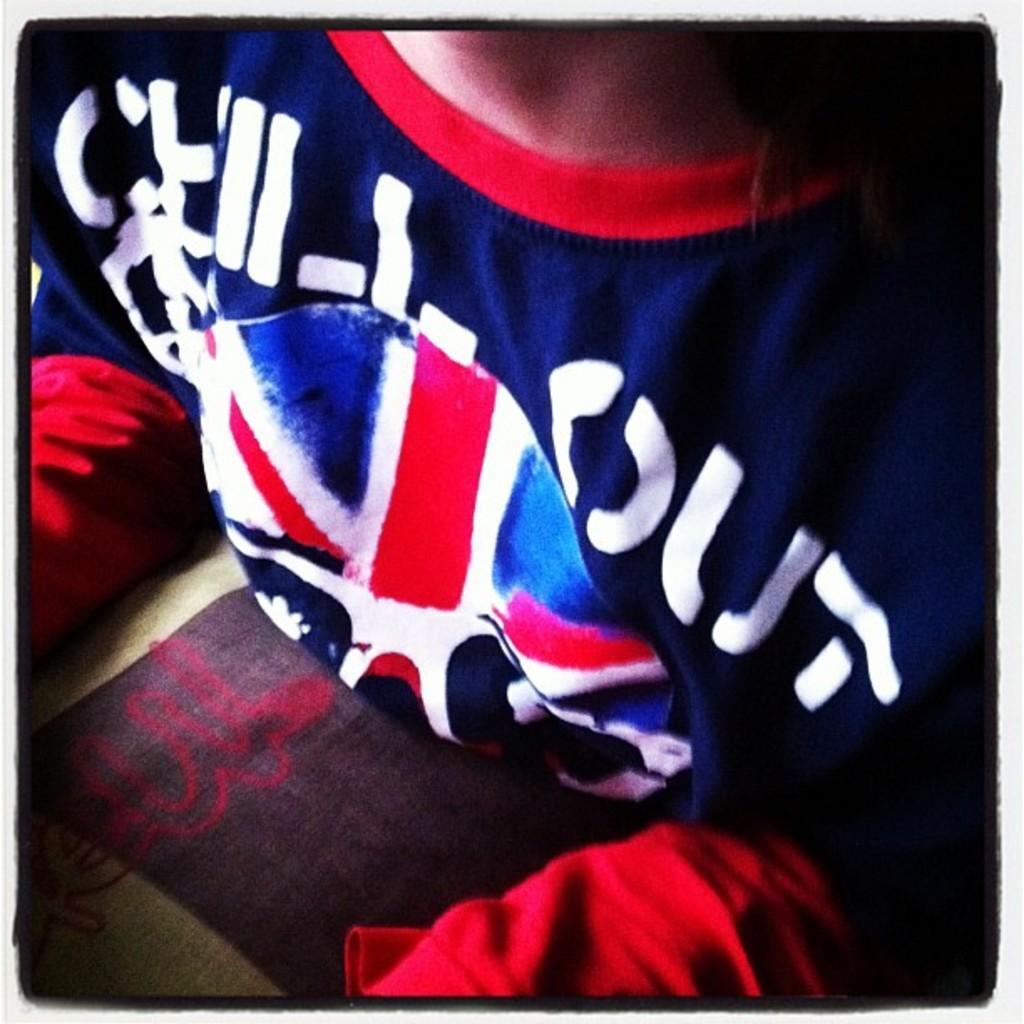<image>
Create a compact narrative representing the image presented. The only word clearly seen on this jersey is OUT and I cannot tell what is written before it. 